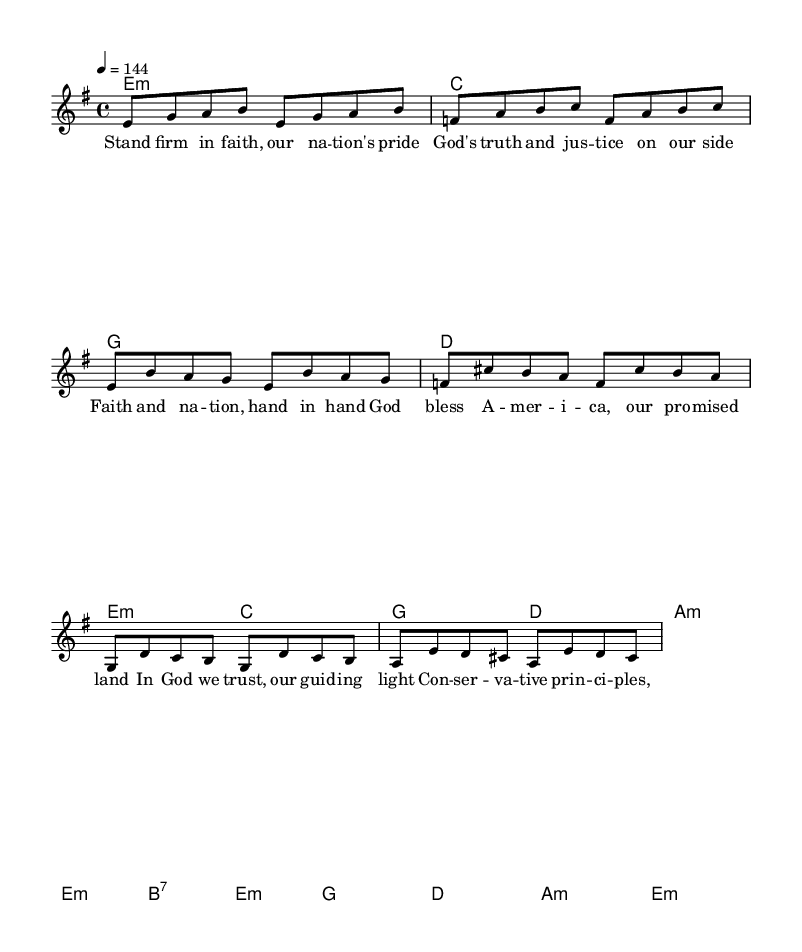What is the key signature of this music? The key signature is E minor, which has one sharp (F#). This can be determined by observing the key signature indicated at the beginning of the staff.
Answer: E minor What is the time signature of the piece? The time signature is 4/4, meaning there are four beats in each measure and the quarter note receives one beat. This is visible in the notation near the beginning of the staff.
Answer: 4/4 What is the tempo marking of this music? The tempo marking is 144 beats per minute, which indicates the speed of the music. It appears at the start of the piece, showing how quickly the music should be played.
Answer: 144 What is the chorus's first line? The first line of the chorus is "Faith and nation, hand in hand." This is found beneath the melody in the lyrics section, aligned with the corresponding melody notes.
Answer: Faith and nation, hand in hand How many distinct sections are there in the piece? There are three distinct sections: verse, chorus, and bridge. Each section contains different musical phrases and lyrics, which is indicated by how the melody and lyrics are organized.
Answer: Three What is a core theme expressed in the lyrics? A core theme expressed in the lyrics is patriotism intertwined with faith. Phrases about standing firm in faith and a blessing for America show this theme clearly within the words.
Answer: Patriotism 